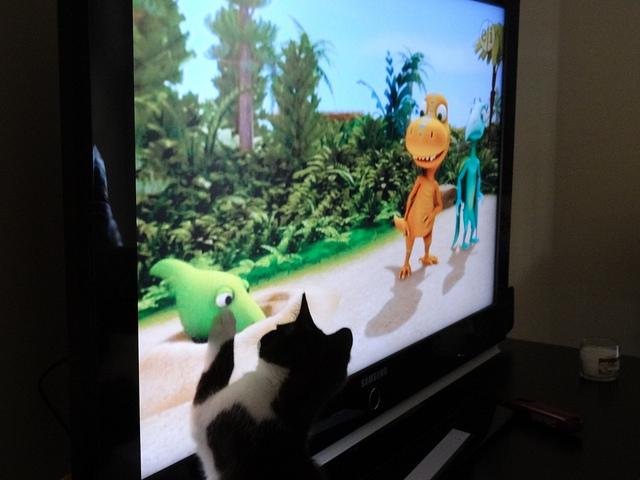Are there trees in this scene?
Be succinct. Yes. Is this cat trying to catch the fish?
Answer briefly. Yes. What is the cat doing?
Give a very brief answer. Playing with tv. Is the TV show for children?
Quick response, please. Yes. What room of a home might this depict?
Short answer required. Living room. Which pterodactyl is female?
Answer briefly. Yes. 